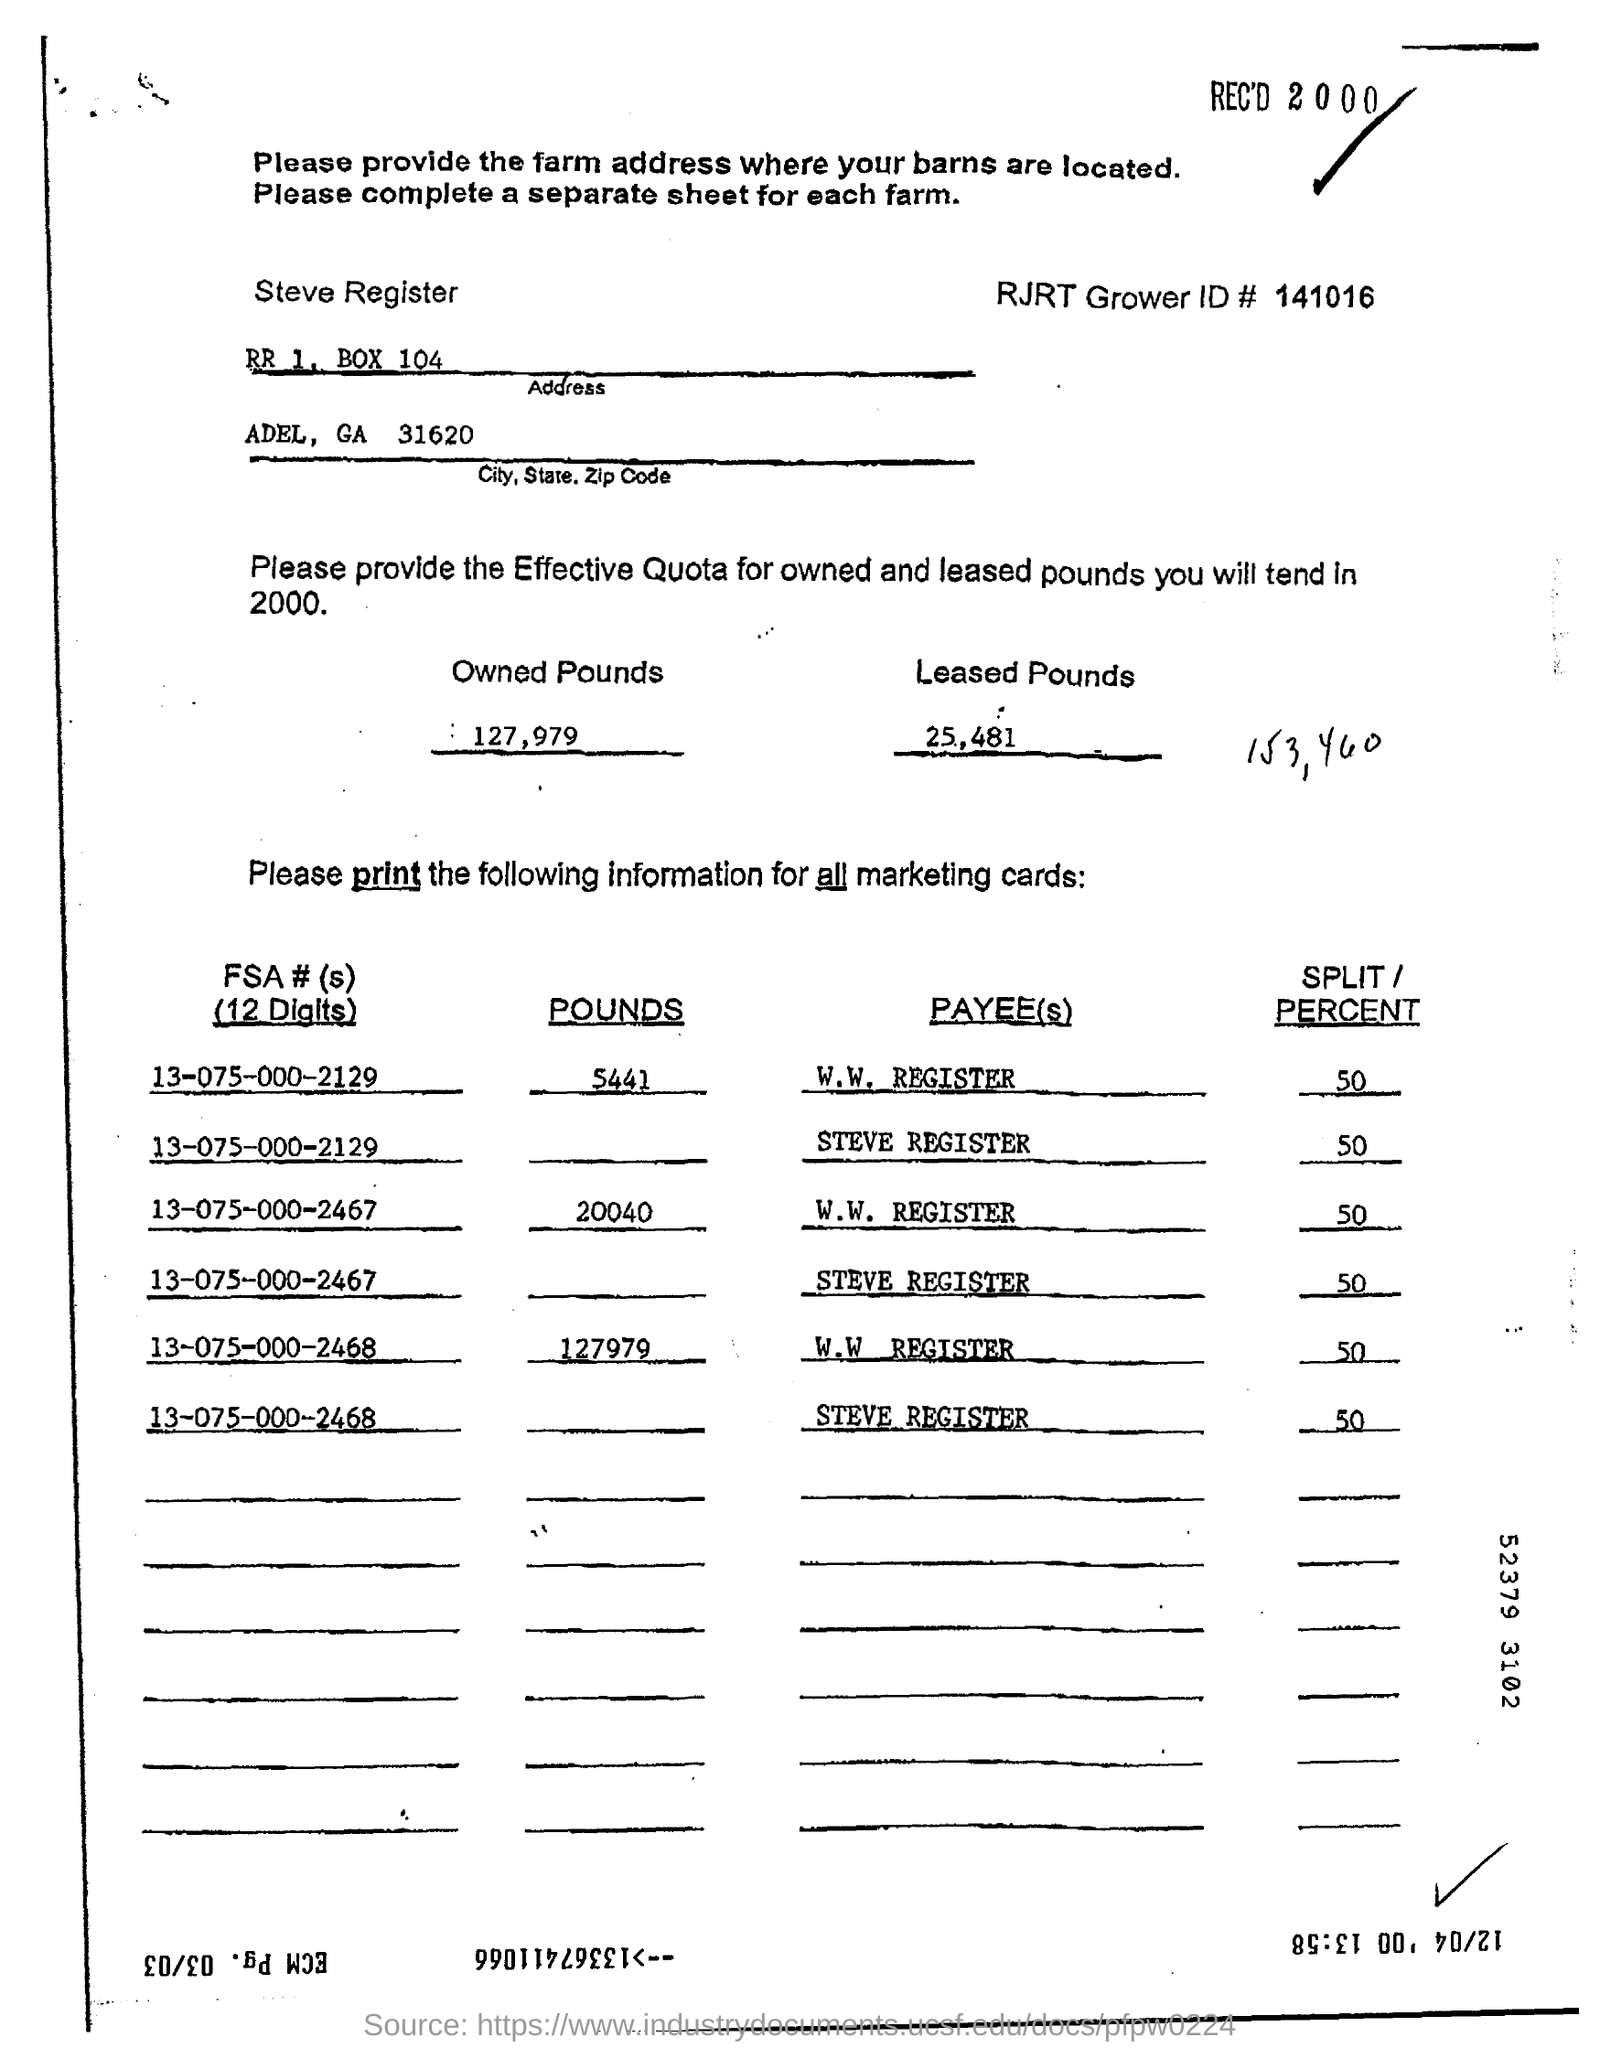What is the RJRT Grower ID#?
Your answer should be very brief. 141016. 